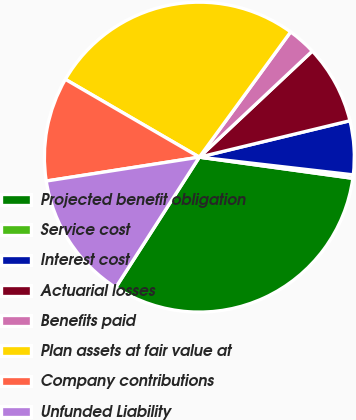<chart> <loc_0><loc_0><loc_500><loc_500><pie_chart><fcel>Projected benefit obligation<fcel>Service cost<fcel>Interest cost<fcel>Actuarial losses<fcel>Benefits paid<fcel>Plan assets at fair value at<fcel>Company contributions<fcel>Unfunded Liability<nl><fcel>31.89%<fcel>0.36%<fcel>5.6%<fcel>8.22%<fcel>2.98%<fcel>26.65%<fcel>10.84%<fcel>13.46%<nl></chart> 